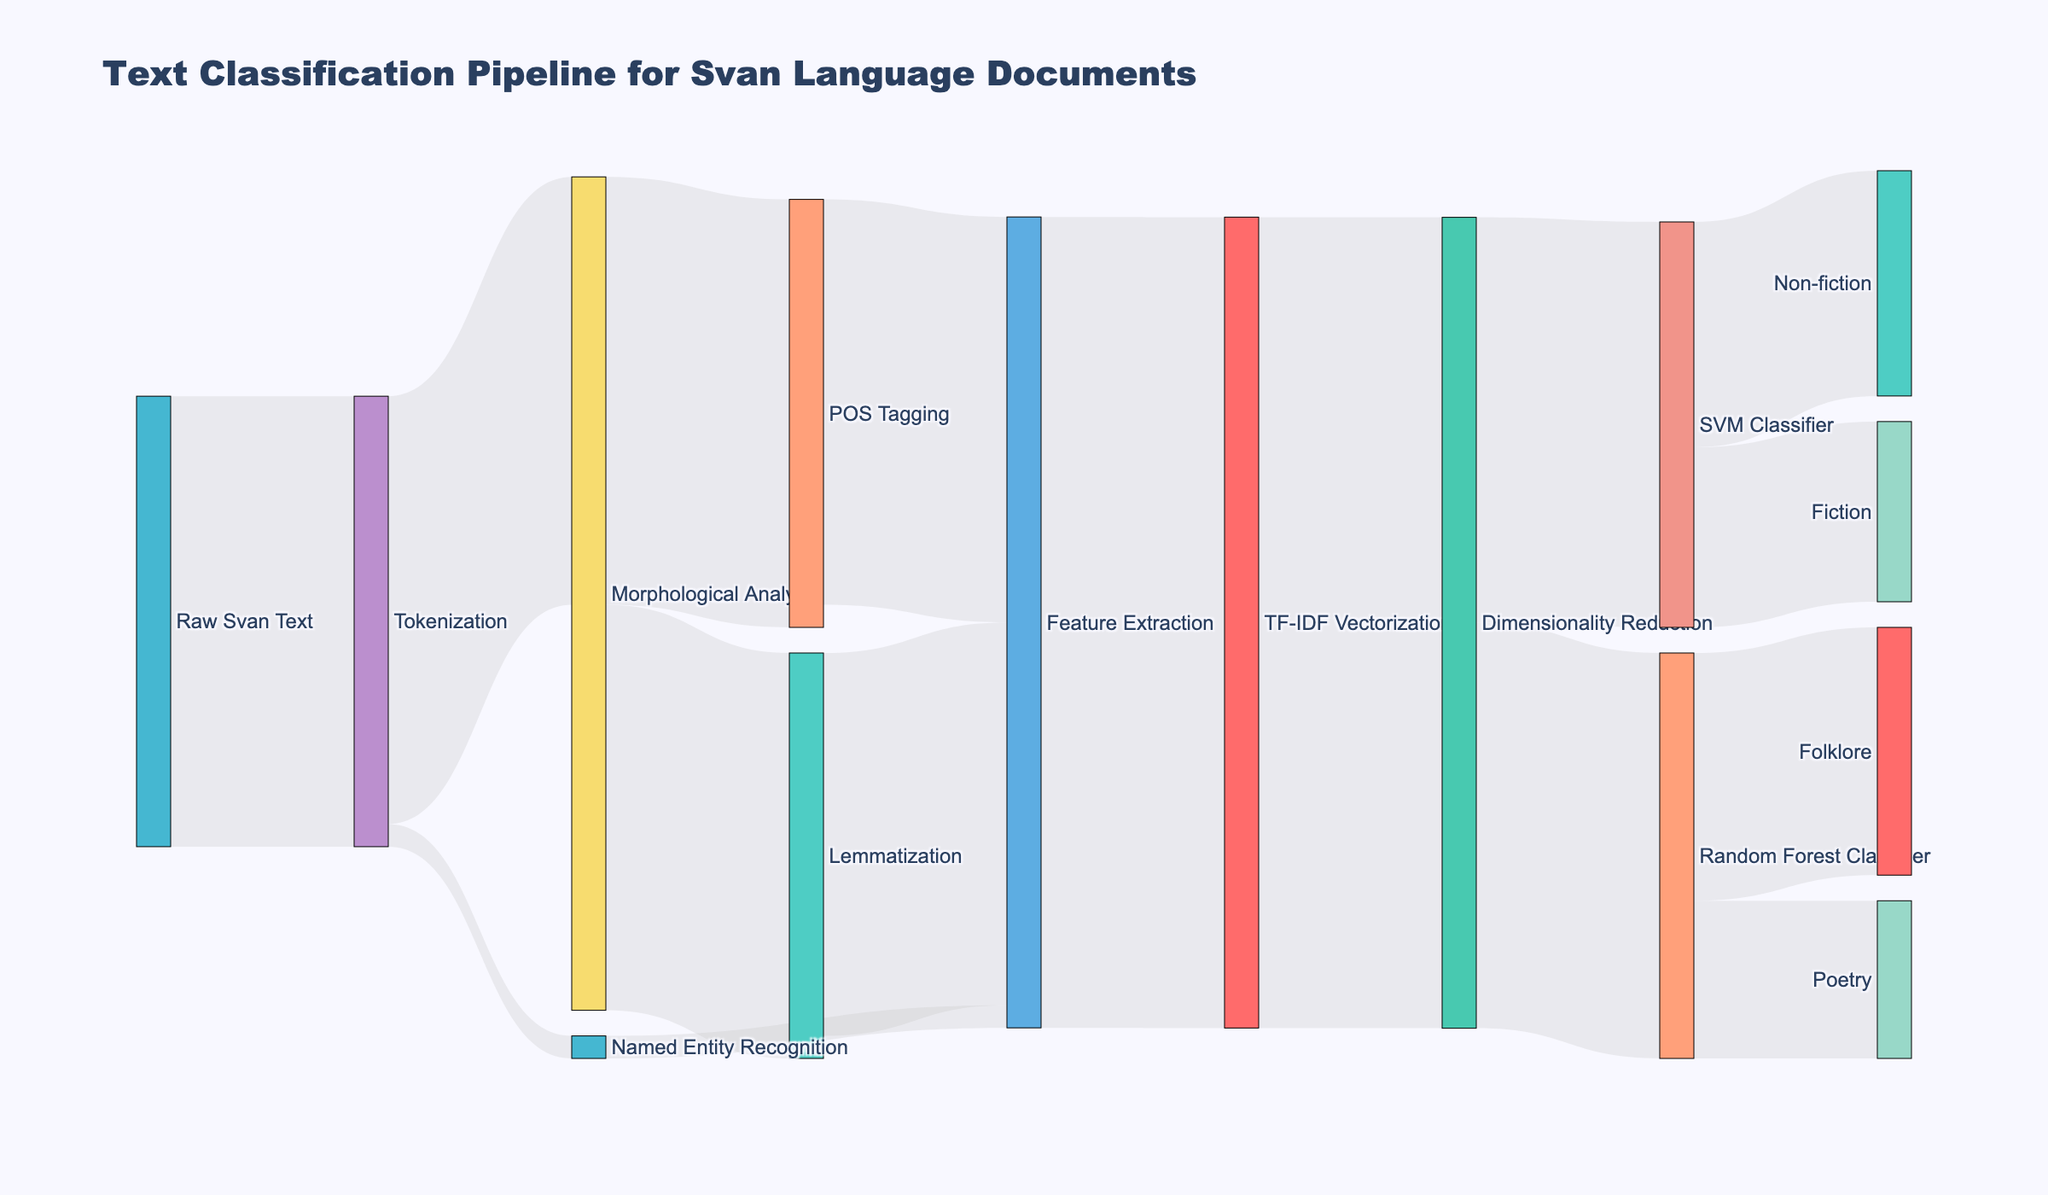what is the title of the figure? The title is typically located at the top of the figure and provides a general overview of what the figure is about. In this case, the title is “Text Classification Pipeline for Svan Language Documents.”
Answer: Text Classification Pipeline for Svan Language Documents which step has the highest data value flowing into it from Tokenization? By examining the figure, we see that the Tokenization step branches into Morphological Analysis and Named Entity Recognition. Among these, Morphological Analysis has the highest data value of 950 flowing into it.
Answer: Morphological Analysis how many distinct nodes are present in the Sankey diagram? To find out the total number of distinct nodes, count all unique nodes: Raw Svan Text, Tokenization, Morphological Analysis, Named Entity Recognition, Lemmatization, POS Tagging, Feature Extraction, TF-IDF Vectorization, Dimensionality Reduction, SVM Classifier, Random Forest Classifier, Fiction, Non-fiction, Poetry, and Folklore, which sums up to 14 nodes.
Answer: 14 how much data does the TF-IDF Vectorization send to Dimensionality Reduction? By looking at the flow from TF-IDF Vectorization to Dimensionality Reduction, we see a value of 1800 indicating how much data is transferred.
Answer: 1800 what is the total data value used for Feature Extraction? The data value for Feature Extraction can be computed by adding all incoming flows: Lemmatization (850), POS Tagging (900), and Named Entity Recognition (50), resulting in a total of 1800.
Answer: 1800 which classifier has the most output categories? By examining the Classifier nodes, we observe that the Random Forest Classifier has 2 output categories (Poetry and Folklore) and so does the SVM Classifier (Fiction and Non-fiction). Since both classifiers have an equal number of output categories, the answer must mention this detail.
Answer: Both (2 categories each) which category receives the least data from the classifiers? By comparing the data values flowing into different categories from the classifiers: Fiction (400), Non-fiction (500), Poetry (350), and Folklore (550), Poetry receives the least data.
Answer: Poetry what are the final categories in this pipeline? The final categories can be identified at the last stage of the pipeline. Here, they are Fiction, Non-fiction, Poetry, and Folklore.
Answer: Fiction, Non-fiction, Poetry, Folklore how does the data value for Lemmatization compare with POS Tagging within Morphological Analysis? For Morphological Analysis, the next steps are Lemmatization and POS Tagging. Lemmatization receives 900, whereas POS Tagging receives 950. Thus, POS Tagging has a higher data value compared to Lemmatization.
Answer: POS Tagging has a higher data value what percentage of the raw text undergoes Named Entity Recognition? To find the percentage, divide the data value for Named Entity Recognition by the total data value flowing from Raw Svan Text, then multiply by 100. That is (50 / 1000) * 100 = 5%.
Answer: 5% 